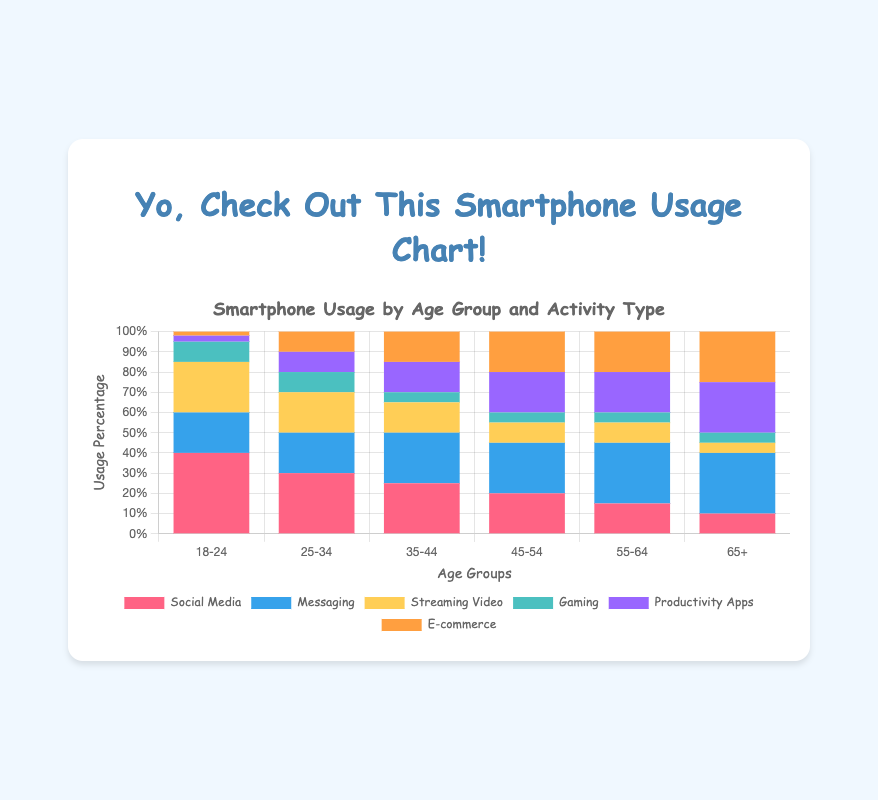What age group spends the highest percentage of time on Social Media? By examining the figure, it's clear that the bar representing Social Media usage is the tallest for the age group 18-24.
Answer: 18-24 What's the total percentage of smartphone usage for the age group 25-34? Summing up the segments for each activity type in the age group 25-34 gives: 30 (Social Media) + 20 (Messaging) + 20 (Streaming Video) + 10 (Gaming) + 10 (Productivity Apps) + 10 (E-commerce) = 100%.
Answer: 100% Which activity has the least percentage of usage in the age group 55-64? Observing the bars for the age group 55-64, we see that Gaming has the smallest segment at 5%.
Answer: Gaming Compare the percentage of Messaging usage between the age groups 18-24 and 65+. What do you notice? The figure shows that Messaging is at 20% for the age group 18-24 and 30% for the age group 65+. Thus, Messaging usage is higher in the 65+ age group compared to the 18-24 age group.
Answer: 65+ has higher Messaging usage Which two age groups spend an equal percentage of time on E-commerce? The E-commerce bars for the age groups 45-54 and 55-64 are both 20%.
Answer: 45-54 and 55-64 For the age group 35-44, how much higher is the percentage for Productivity Apps compared to Gaming? The percentage for Productivity Apps in the age group 35-44 is 15%, while for Gaming, it is 5%. The difference is 15% - 5% = 10%.
Answer: 10% What is the total percentage of Messaging and Productivity Apps usage for the age group 65+? The Messaging usage is 30% and the Productivity Apps usage is 25% for the age group 65+. Adding them up gives 30% + 25% = 55%.
Answer: 55% Which activity shows a decreasing trend as age increases, across all age groups? Observing the figure, Social Media decreases from 40% in the age group 18-24 to 10% in the age group 65+, showing a consistent decreasing trend.
Answer: Social Media How many age groups have greater or equal Messaging usage compared to Social Media in the 18-24 age group? Social Media in the age group 18-24 is 40%, and the bars for Messaging are all below this percentage, so there are no age groups with greater or equal Messaging usage.
Answer: 0 What visual element in the chart indicates the percentage of smartphone usage for each activity in each age group? The height of the stacked bars represents the percentage of smartphone usage for each activity in each age group.
Answer: Height of the stacked bars 